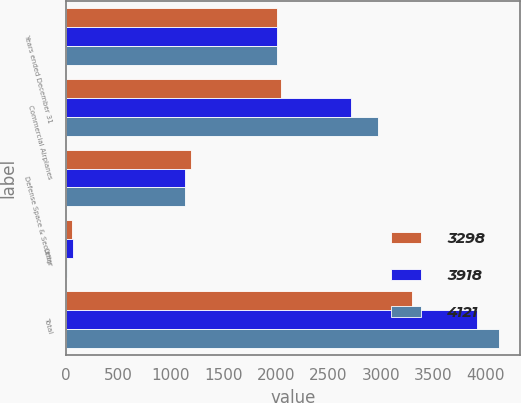<chart> <loc_0><loc_0><loc_500><loc_500><stacked_bar_chart><ecel><fcel>Years ended December 31<fcel>Commercial Airplanes<fcel>Defense Space & Security<fcel>Other<fcel>Total<nl><fcel>3298<fcel>2012<fcel>2049<fcel>1189<fcel>60<fcel>3298<nl><fcel>3918<fcel>2011<fcel>2715<fcel>1138<fcel>65<fcel>3918<nl><fcel>4121<fcel>2010<fcel>2975<fcel>1136<fcel>10<fcel>4121<nl></chart> 